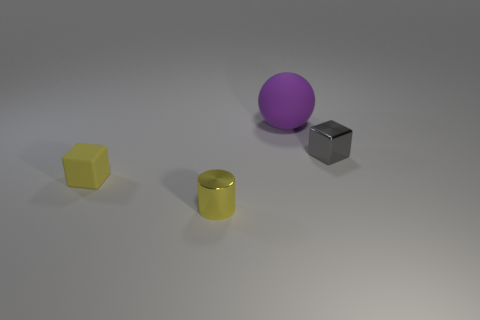Add 1 big purple objects. How many objects exist? 5 Subtract all spheres. How many objects are left? 3 Subtract 0 brown blocks. How many objects are left? 4 Subtract all small yellow cylinders. Subtract all big matte balls. How many objects are left? 2 Add 3 gray metal cubes. How many gray metal cubes are left? 4 Add 1 big purple balls. How many big purple balls exist? 2 